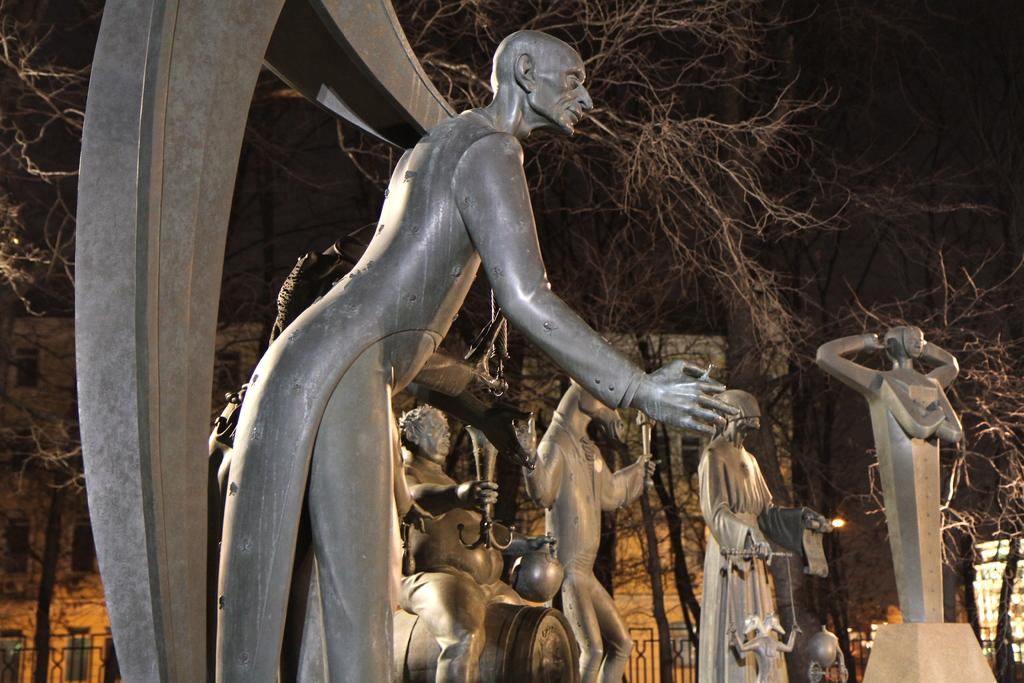What type of art is present in the image? There are sculptures in the image. What color are the sculptures? The sculptures are gray in color. What can be seen in the background of the image? There are dried trees and a building with windows in the background. What feature is present around the building? There is a railing around the building. How does the cable connect to the sculptures in the image? There is no cable present in the image; it only features sculptures, dried trees, a building, and a railing. 